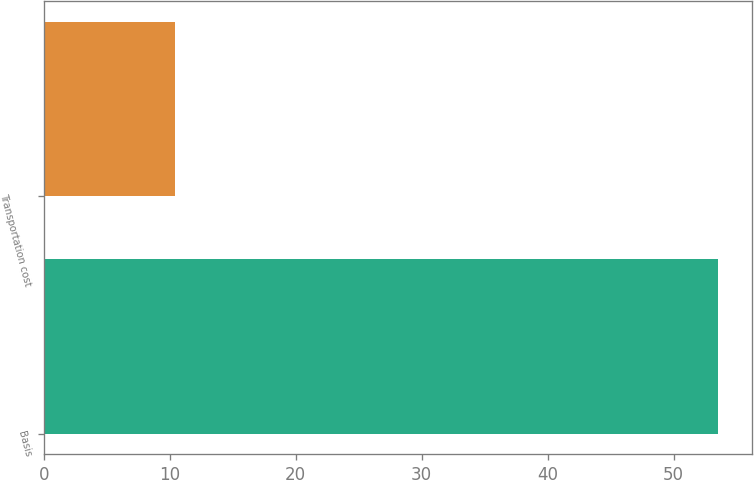<chart> <loc_0><loc_0><loc_500><loc_500><bar_chart><fcel>Basis<fcel>Transportation cost<nl><fcel>53.5<fcel>10.4<nl></chart> 